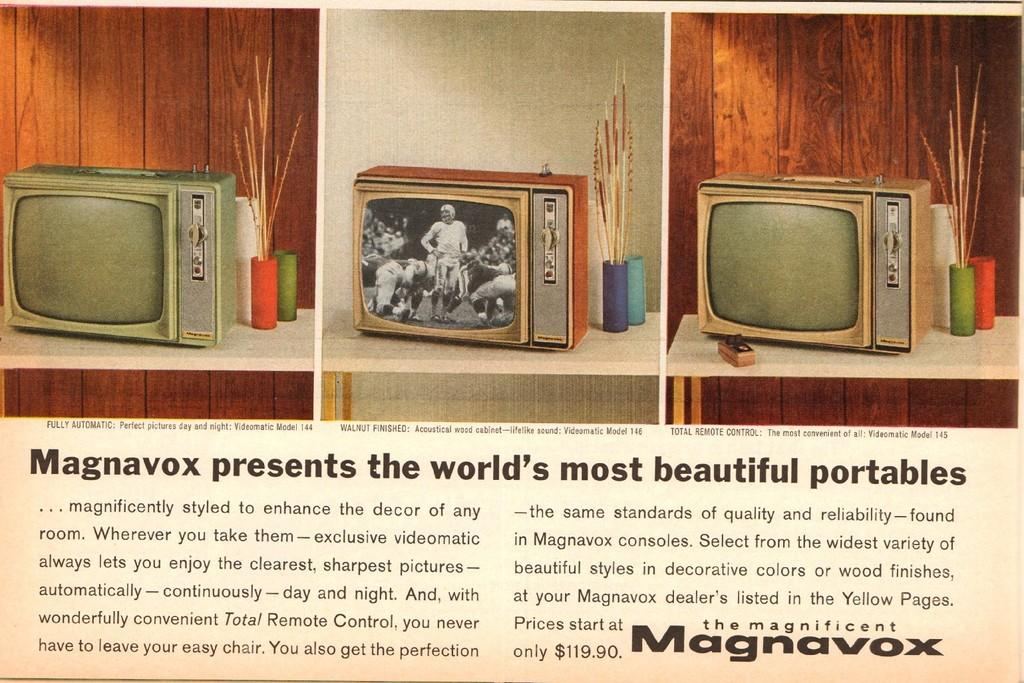<image>
Offer a succinct explanation of the picture presented. a television that has the word Magnavox on it 